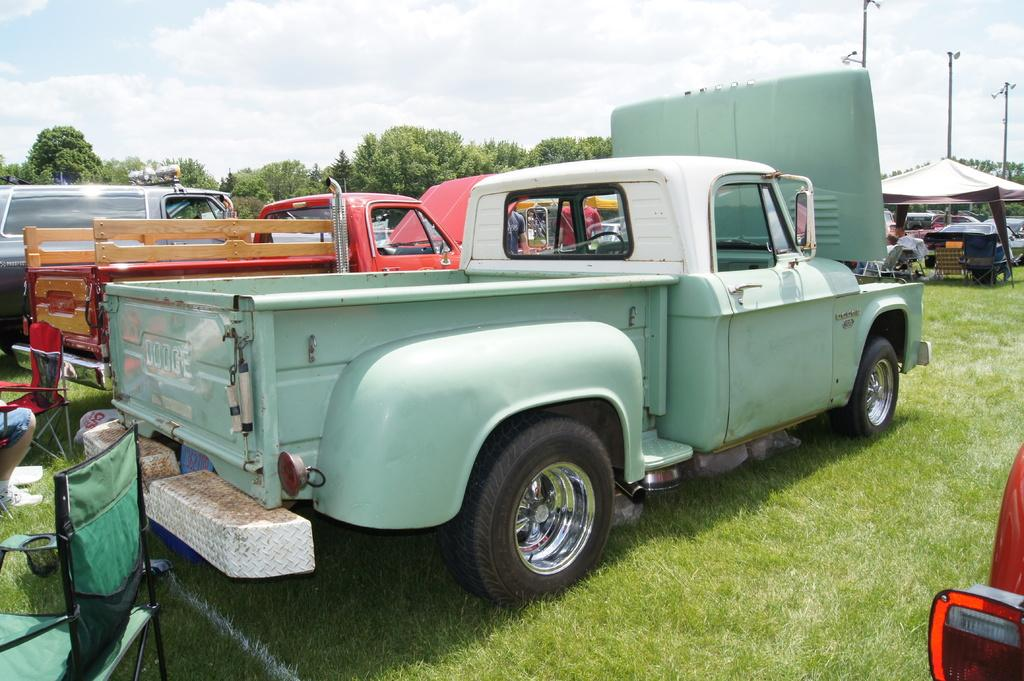What type of furniture can be seen in the image? There are chairs in the image. What else is present in the image besides chairs? There are vehicles, grass, a tent, poles, trees, some objects, and people in the image. Can you describe the setting of the image? The image appears to be outdoors, with grass, trees, and a tent visible. What is visible in the background of the image? The sky is visible in the background of the image, with clouds present. How does the image increase the brain's capacity? The image does not have any direct impact on the brain's capacity. Can you make a wish while looking at the image? Making a wish is not related to the content of the image. 